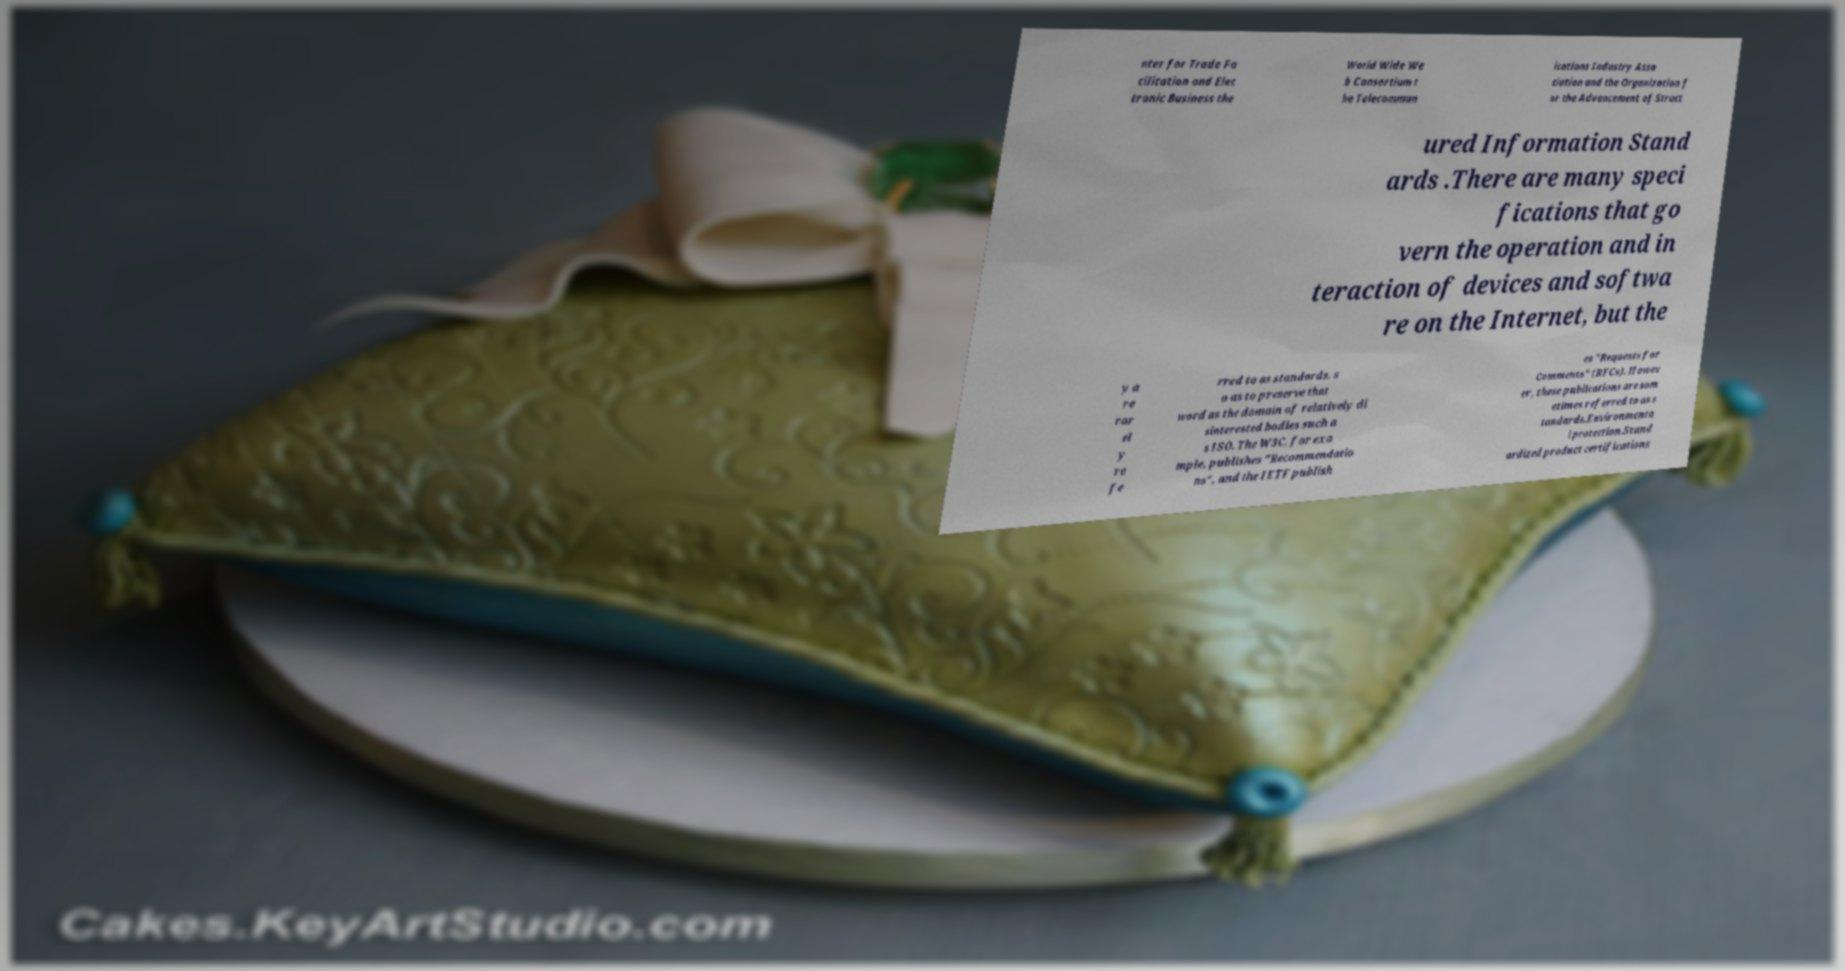Can you read and provide the text displayed in the image?This photo seems to have some interesting text. Can you extract and type it out for me? nter for Trade Fa cilitation and Elec tronic Business the World Wide We b Consortium t he Telecommun ications Industry Asso ciation and the Organization f or the Advancement of Struct ured Information Stand ards .There are many speci fications that go vern the operation and in teraction of devices and softwa re on the Internet, but the y a re rar el y re fe rred to as standards, s o as to preserve that word as the domain of relatively di sinterested bodies such a s ISO. The W3C, for exa mple, publishes "Recommendatio ns", and the IETF publish es "Requests for Comments" (RFCs). Howev er, these publications are som etimes referred to as s tandards.Environmenta l protection.Stand ardized product certifications 